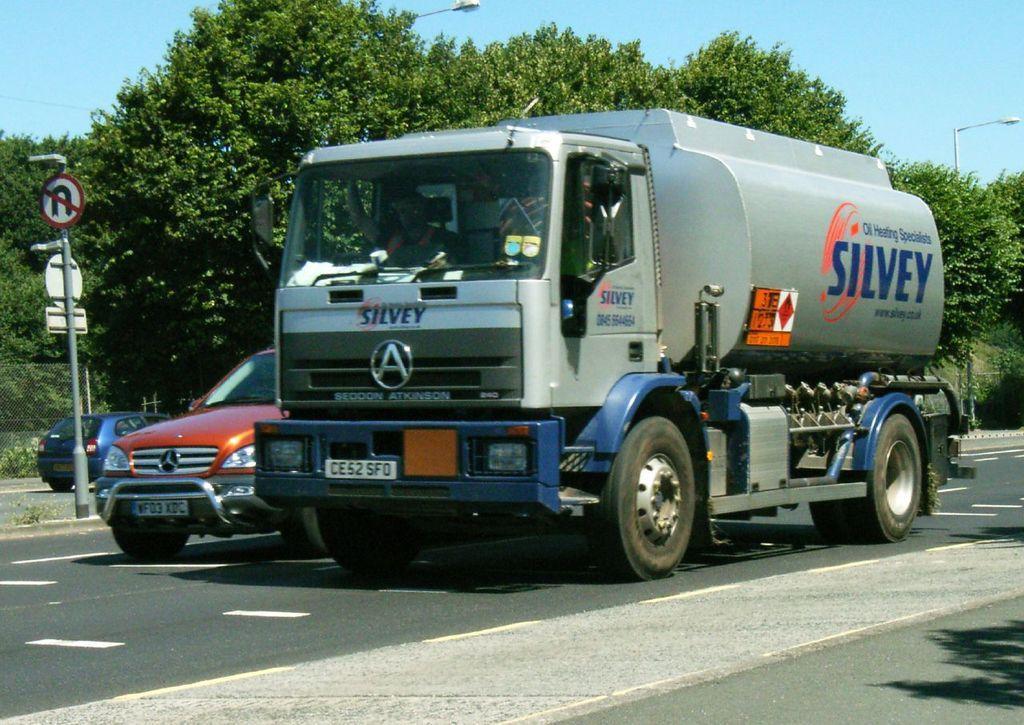In one or two sentences, can you explain what this image depicts? This is the truck which is silver in color. I can see the person driving the truck. These are the cars. This is the sign board attached to the pole. This is the road. At background I can see tree and street lights. 